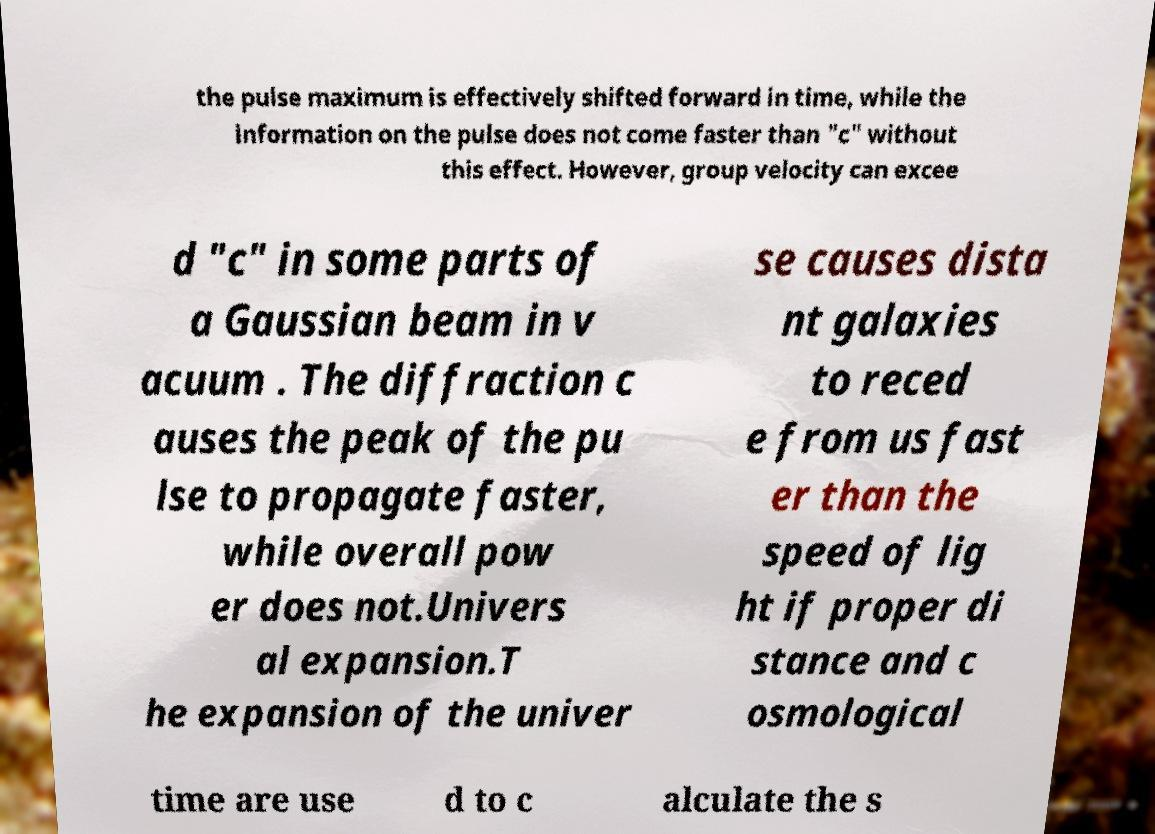What messages or text are displayed in this image? I need them in a readable, typed format. the pulse maximum is effectively shifted forward in time, while the information on the pulse does not come faster than "c" without this effect. However, group velocity can excee d "c" in some parts of a Gaussian beam in v acuum . The diffraction c auses the peak of the pu lse to propagate faster, while overall pow er does not.Univers al expansion.T he expansion of the univer se causes dista nt galaxies to reced e from us fast er than the speed of lig ht if proper di stance and c osmological time are use d to c alculate the s 